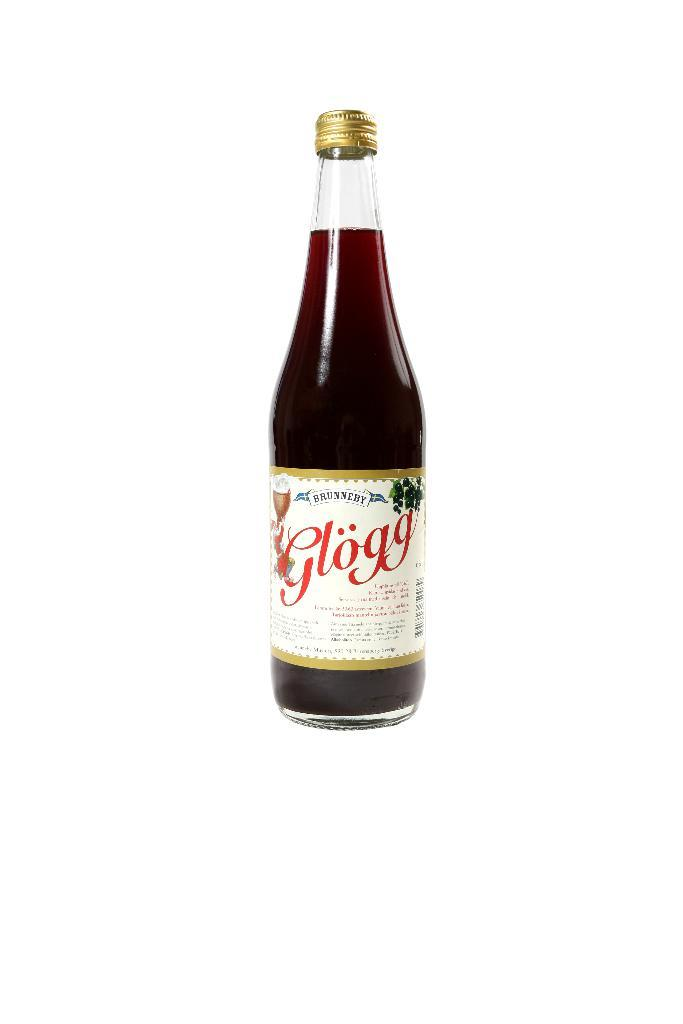<image>
Share a concise interpretation of the image provided. a bottle of brunneby glogg with a white label on it 